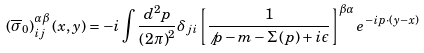Convert formula to latex. <formula><loc_0><loc_0><loc_500><loc_500>\left ( \overline { \sigma } _ { 0 } \right ) _ { i j } ^ { \alpha \beta } \left ( x , y \right ) = - i \int \frac { d ^ { 2 } p } { \left ( 2 \pi \right ) ^ { 2 } } \delta _ { j i } \left [ \frac { 1 } { \not p - m - \Sigma \left ( p \right ) + i \epsilon } \right ] ^ { \beta \alpha } e ^ { - i p \cdot \left ( y - x \right ) }</formula> 